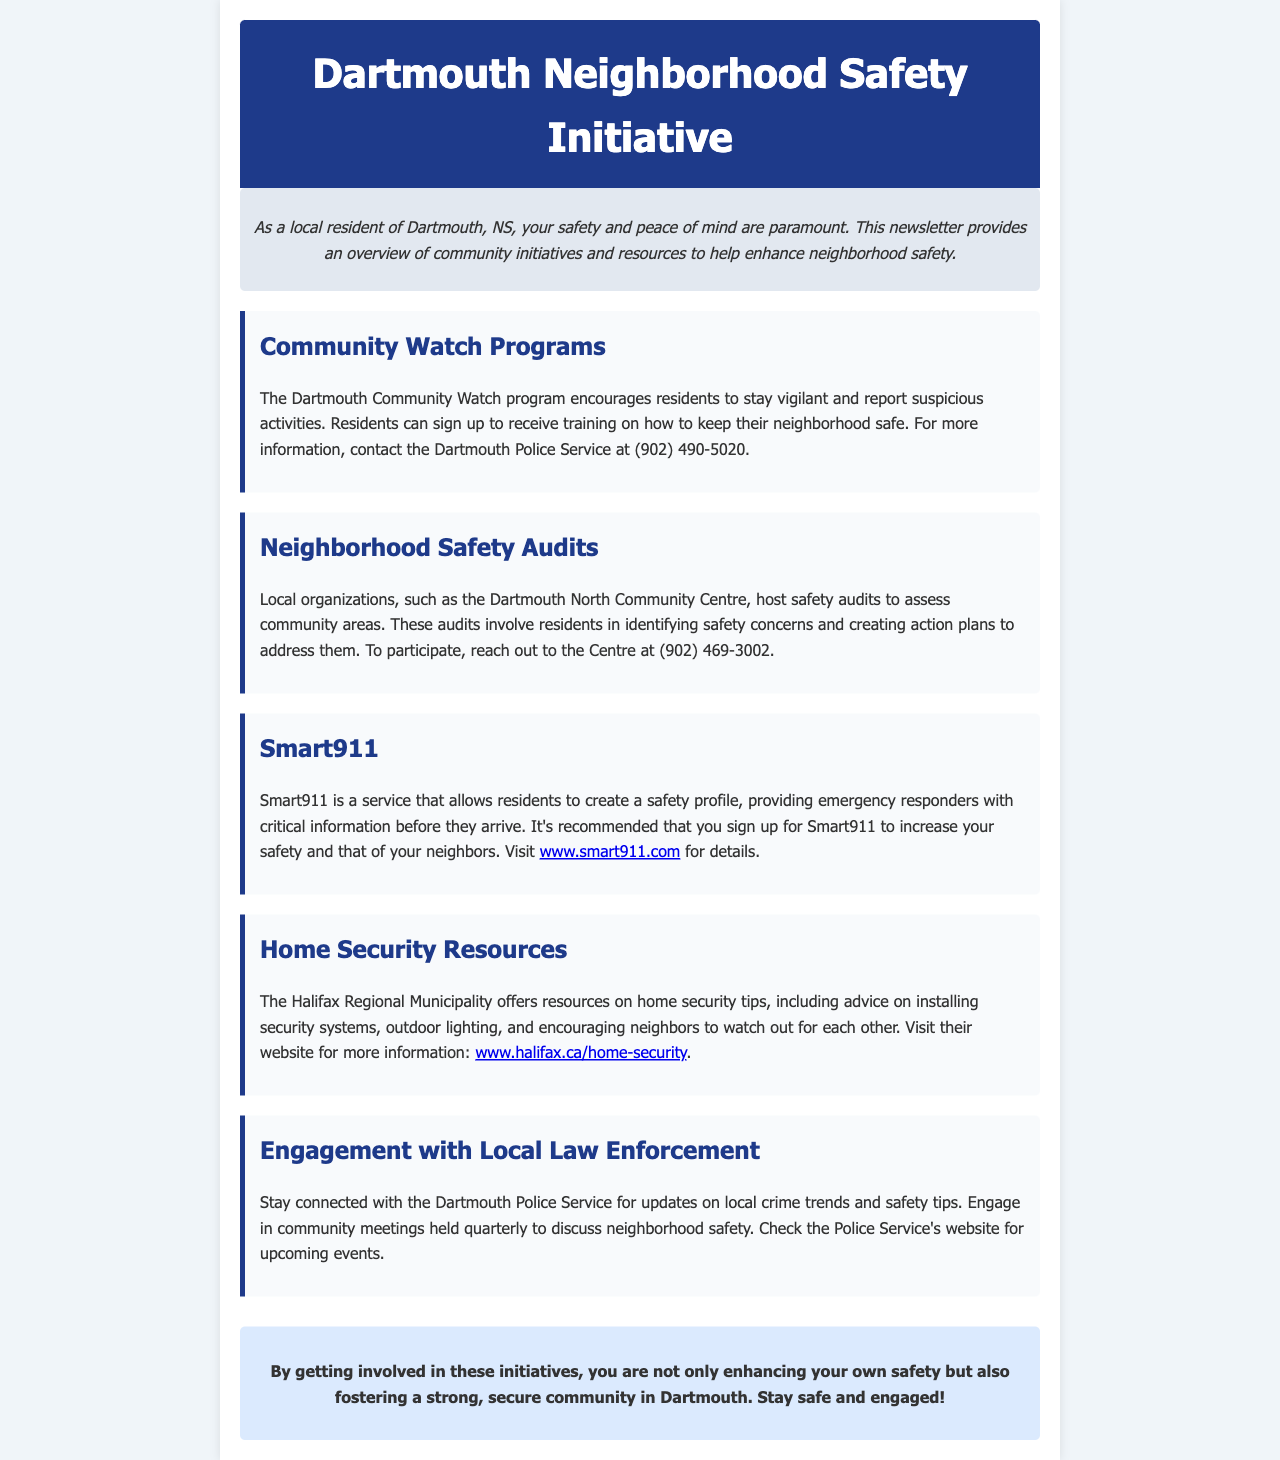What is the contact number for the Dartmouth Police Service? The contact number for the Dartmouth Police Service is mentioned in the document as (902) 490-5020.
Answer: (902) 490-5020 What program encourages residents to stay vigilant and report suspicious activities? The document specifically mentions the Dartmouth Community Watch program as one that encourages vigilance and reporting.
Answer: Dartmouth Community Watch program Which local organization hosts safety audits? The document states that the Dartmouth North Community Centre hosts safety audits.
Answer: Dartmouth North Community Centre What service allows residents to create a safety profile for emergency responders? The document indicates that Smart911 is the service that allows this safety profiling.
Answer: Smart911 How often are community meetings held to discuss neighborhood safety? The document notes that community meetings are held quarterly.
Answer: Quarterly What website offers information on home security tips? The document provides the Halifax Regional Municipality's website for home security tips.
Answer: www.halifax.ca/home-security Why should residents engage with local law enforcement? The document suggests staying connected for updates on local crime trends and safety tips as a reason for engagement.
Answer: Updates on local crime trends What is the overall goal of getting involved in community safety initiatives? The document concludes that the goal is to enhance personal safety and foster a secure community.
Answer: Enhance personal safety and foster a secure community 